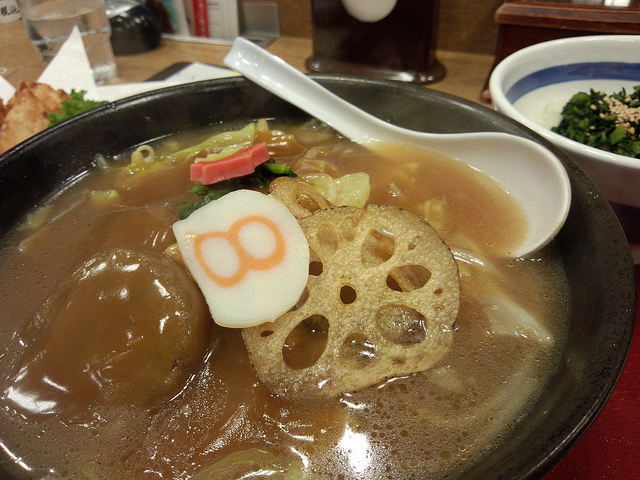<image>Is the food delicious? I don't know if the food is delicious. Its taste can vary from person to person. Is the food delicious? I am not sure if the food is delicious. It can be delicious or not. 